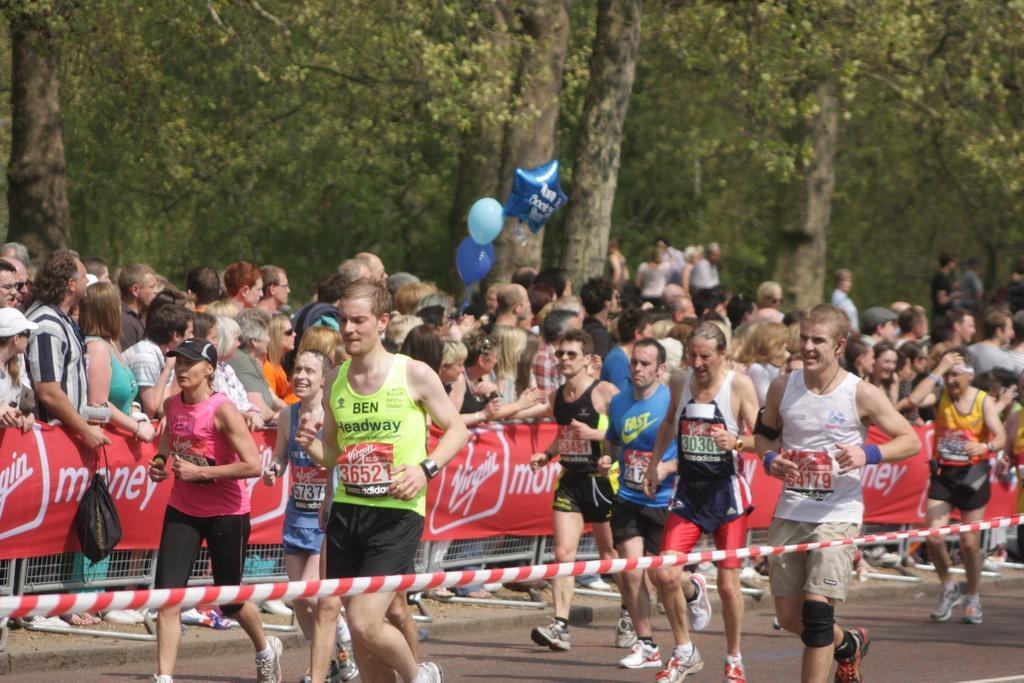Please provide a concise description of this image. In this picture we can see some people are walking on the road, banners, fence, balloons, bag, some objects and a group of people are standing. In the background we can see trees. 